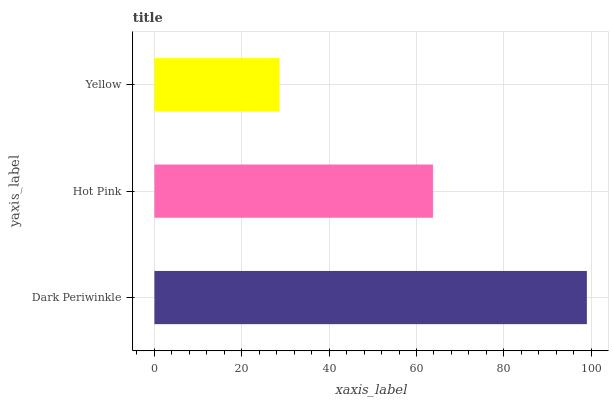Is Yellow the minimum?
Answer yes or no. Yes. Is Dark Periwinkle the maximum?
Answer yes or no. Yes. Is Hot Pink the minimum?
Answer yes or no. No. Is Hot Pink the maximum?
Answer yes or no. No. Is Dark Periwinkle greater than Hot Pink?
Answer yes or no. Yes. Is Hot Pink less than Dark Periwinkle?
Answer yes or no. Yes. Is Hot Pink greater than Dark Periwinkle?
Answer yes or no. No. Is Dark Periwinkle less than Hot Pink?
Answer yes or no. No. Is Hot Pink the high median?
Answer yes or no. Yes. Is Hot Pink the low median?
Answer yes or no. Yes. Is Dark Periwinkle the high median?
Answer yes or no. No. Is Yellow the low median?
Answer yes or no. No. 